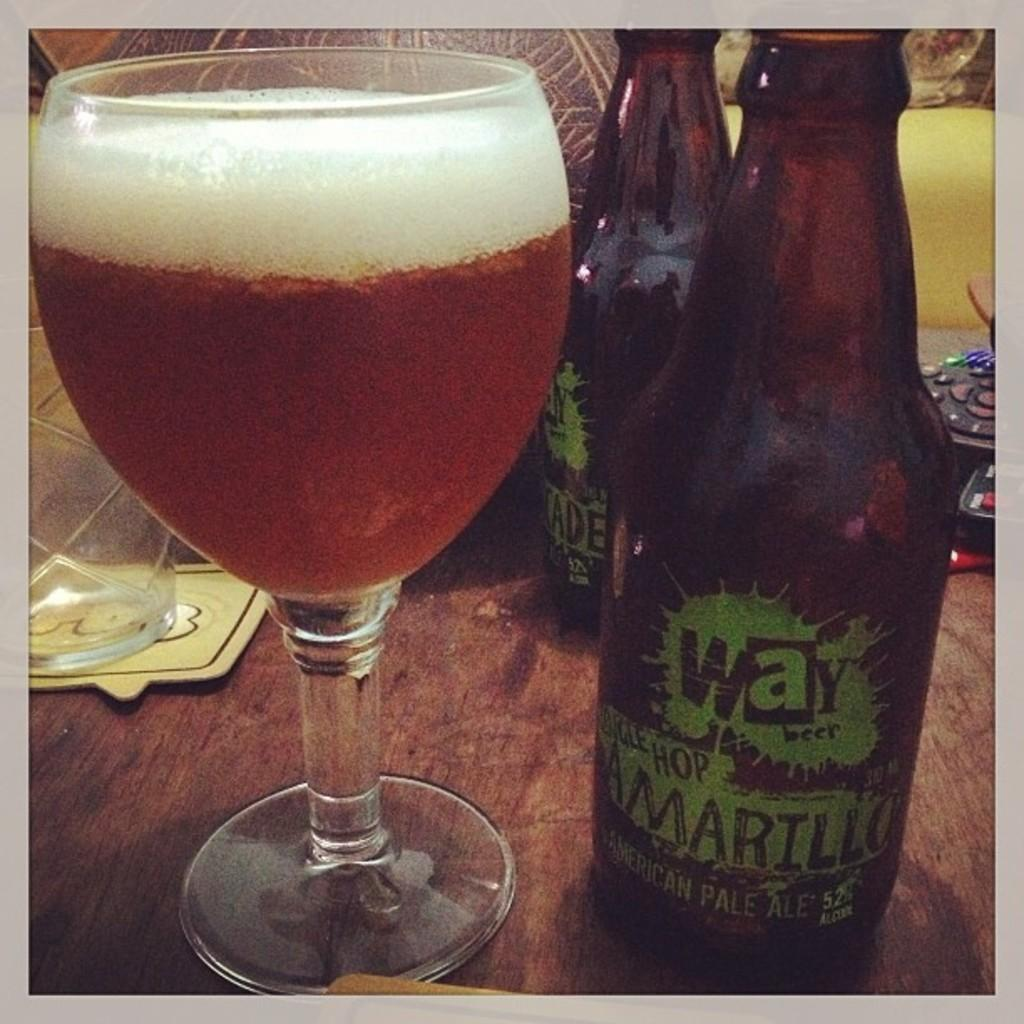<image>
Present a compact description of the photo's key features. A Mexican pale ale bottle stands next to a full beer glass. 